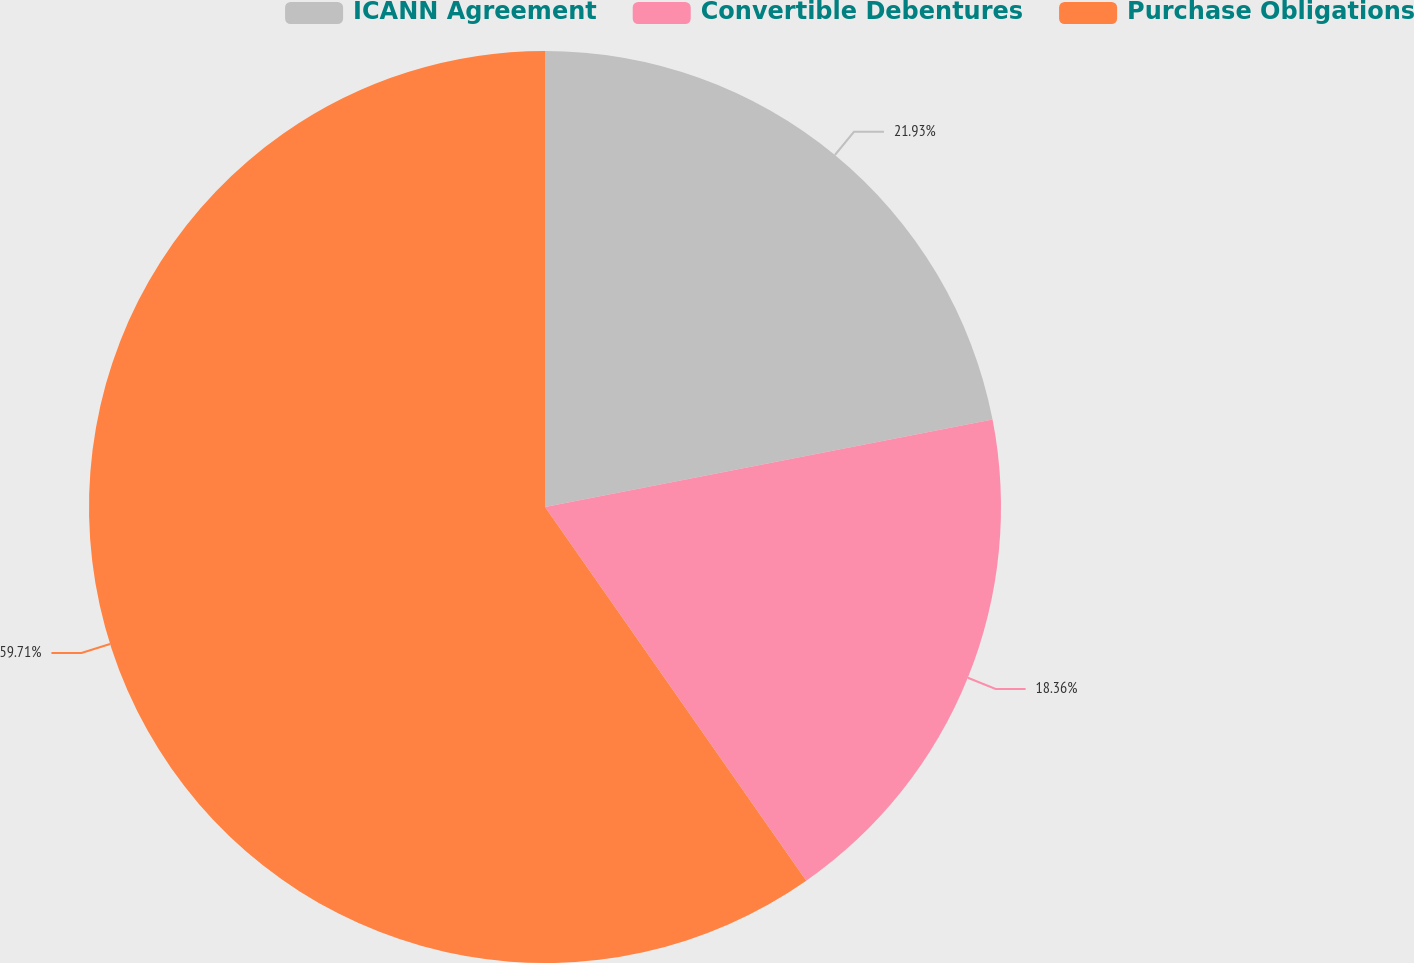Convert chart to OTSL. <chart><loc_0><loc_0><loc_500><loc_500><pie_chart><fcel>ICANN Agreement<fcel>Convertible Debentures<fcel>Purchase Obligations<nl><fcel>21.93%<fcel>18.36%<fcel>59.71%<nl></chart> 